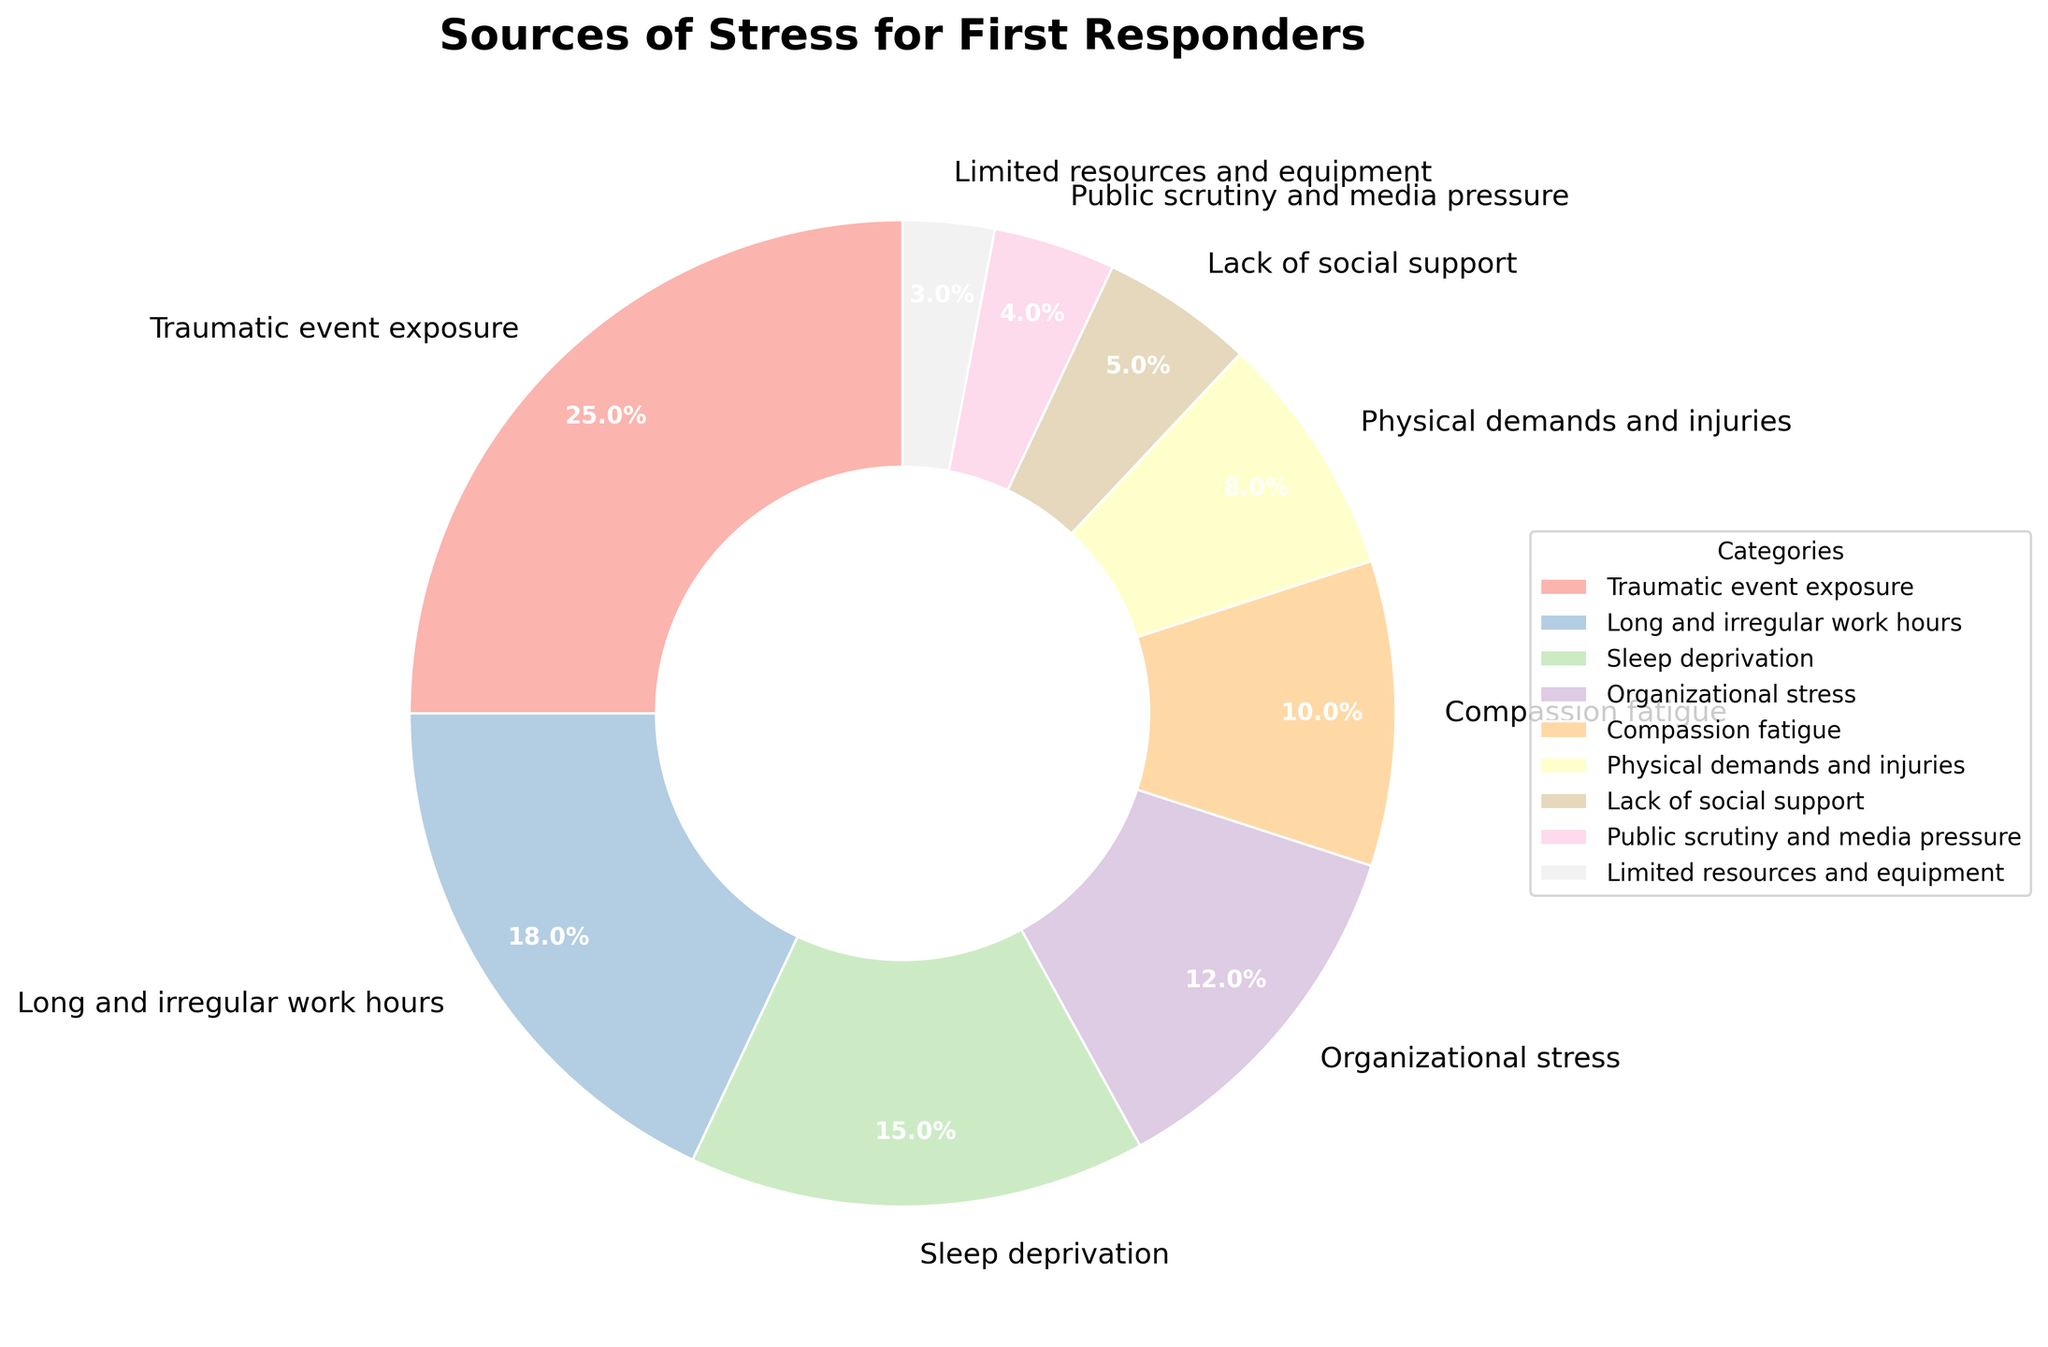What percentage of stress sources are directly related to the nature of the job itself, excluding organizational and societal factors? To find the percentage of stress sources directly related to the nature of the job itself, exclude organizational stress, lack of social support, public scrutiny, and limited resources. Sum the remaining percentages: Traumatic event exposure (25), Long and irregular work hours (18), Sleep deprivation (15), Compassion fatigue (10), and Physical demands and injuries (8). So, 25 + 18 + 15 + 10 + 8 = 76%.
Answer: 76% Which category is the largest source of stress for first responders? The largest source of stress for first responders is the category with the highest percentage. According to the figure, it's Traumatic event exposure with 25%.
Answer: Traumatic event exposure How does the percentage of stress from long and irregular work hours compare to the percentage from organizational stress? Comparing these two percentages requires directly looking at their values in the figure: Long and irregular work hours (18%) and Organizational stress (12%). The difference is 18% - 12% = 6%.
Answer: 6% If you combine the stress percentages from lack of social support and public scrutiny, what is the combined percentage? Sum the percentages of lack of social support (5%) and public scrutiny and media pressure (4%): 5 + 4 = 9%.
Answer: 9% Which sources of stress are represented by the lightest color in the pie chart? To identify the sources of stress represented by the lightest color, look for the segments with the palest pastel shades. It would typically correspond to the smallest percentages, which are Limited resources and equipment (3%), and Public scrutiny and media pressure (4%).
Answer: Limited resources and equipment, Public scrutiny and media pressure What is the combined percentage of stress due to physical demands and injuries and sleep deprivation? To find the combined percentage, sum the percentages of Physical demands and injuries (8%) and Sleep deprivation (15%): 8 + 15 = 23%.
Answer: 23% Between organizational stress and compassion fatigue, which one is a higher source of stress and by how much? Compare the percentages of Organizational stress (12%) and Compassion fatigue (10%). Organizational stress is higher by 12% - 10% = 2%.
Answer: Organizational stress by 2% What percentage of stress factors are below 10% in the chart? Identify stress factors with percentages below 10%: Physical demands and injuries (8%), Lack of social support (5%), Public scrutiny and media pressure (4%), and Limited resources and equipment (3%). Sum these percentages: 8 + 5 + 4 + 3 = 20%.
Answer: 20% Which stress source contributes more: lack of social support or physical demands and injuries? Compare the percentages of Lack of social support (5%) and Physical demands and injuries (8%). Physical demands and injuries is higher.
Answer: Physical demands and injuries What is the percentage difference between the highest and lowest sources of stress? The highest source of stress is Traumatic event exposure (25%), and the lowest is Limited resources and equipment (3%). The difference is 25% - 3% = 22%.
Answer: 22% 